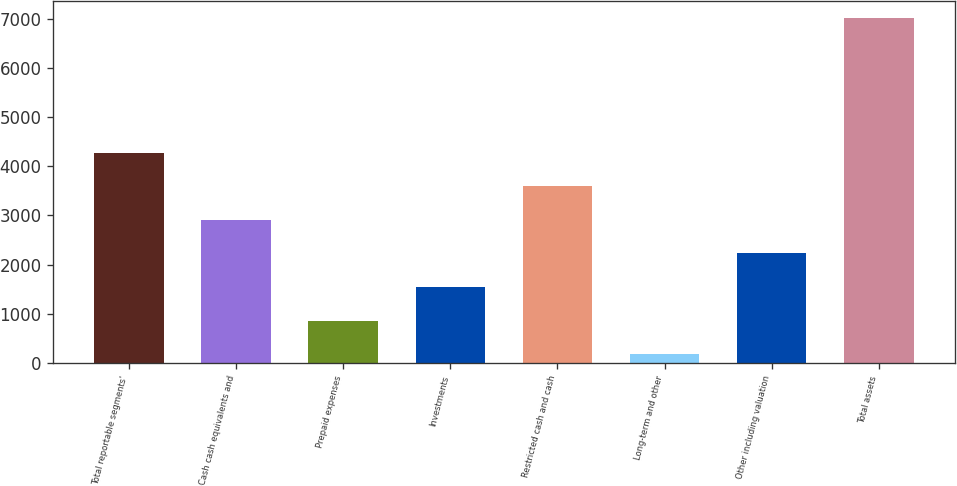Convert chart to OTSL. <chart><loc_0><loc_0><loc_500><loc_500><bar_chart><fcel>Total reportable segments'<fcel>Cash cash equivalents and<fcel>Prepaid expenses<fcel>Investments<fcel>Restricted cash and cash<fcel>Long-term and other<fcel>Other including valuation<fcel>Total assets<nl><fcel>4275.8<fcel>2910.2<fcel>861.8<fcel>1544.6<fcel>3593<fcel>179<fcel>2227.4<fcel>7007<nl></chart> 